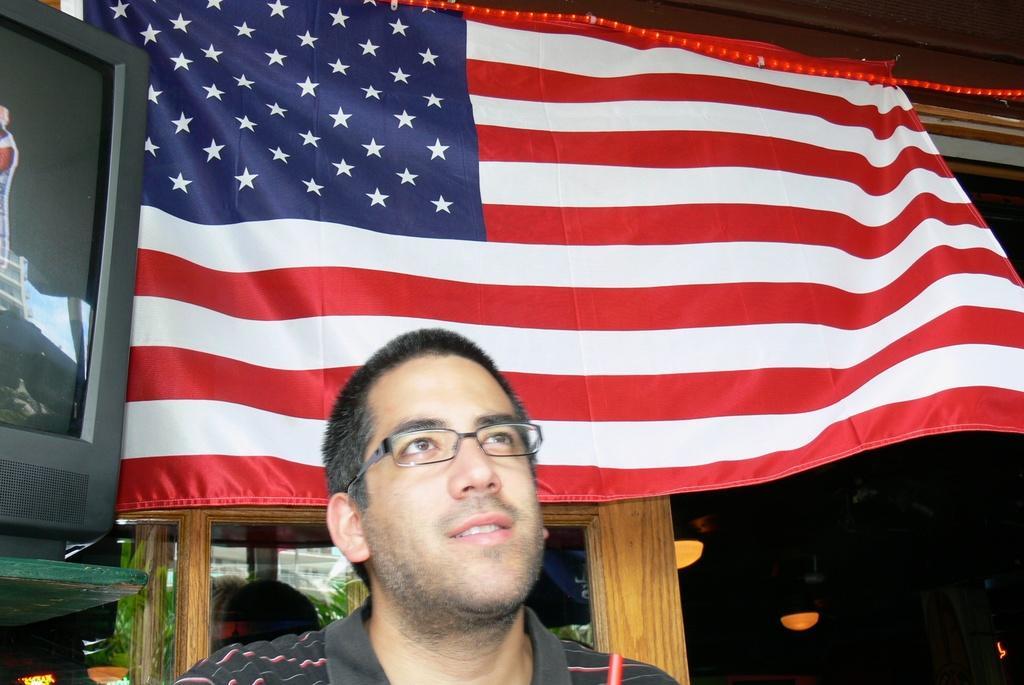How would you summarize this image in a sentence or two? In this picture, we can see a man and behind the man there is a flag, television and there are ceiling lights on the top. 